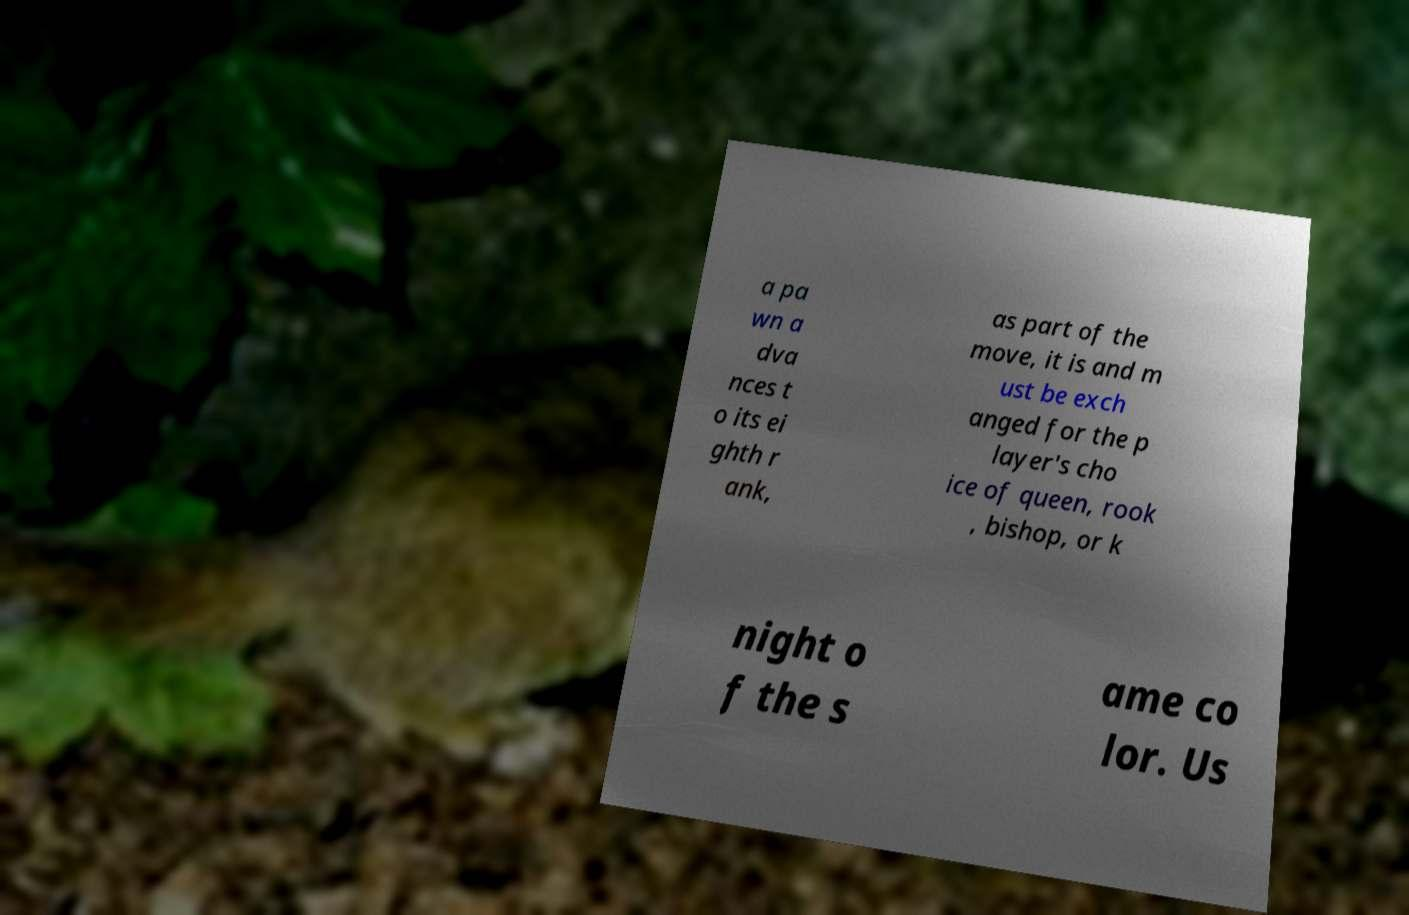Can you accurately transcribe the text from the provided image for me? a pa wn a dva nces t o its ei ghth r ank, as part of the move, it is and m ust be exch anged for the p layer's cho ice of queen, rook , bishop, or k night o f the s ame co lor. Us 